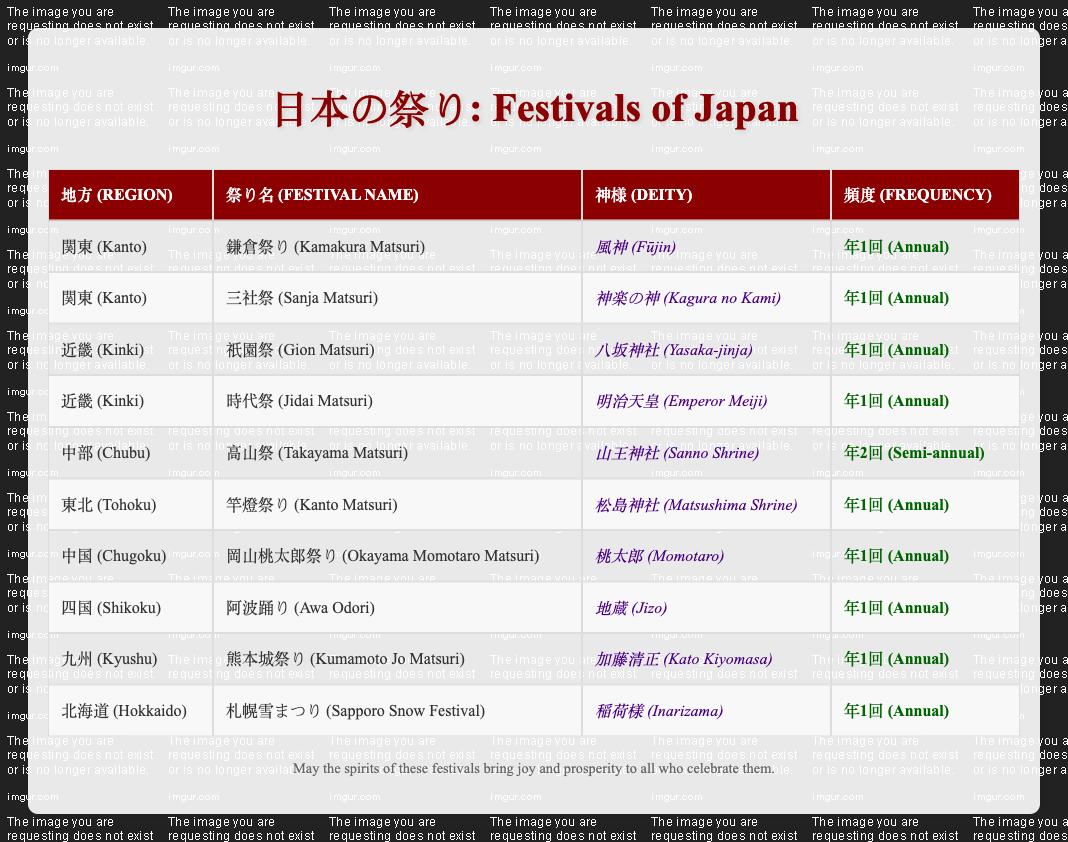What regions have festivals associated with Jizo? Looking at the table, I can see that the only festival associated with Jizo is the Awa Odori in Shikoku. Thus, the answer is Shikoku.
Answer: Shikoku How many festivals are held annually across all regions? By counting the frequency of each festival listed, I identify that all the festivals except for Takayama Matsuri are annual. There are 9 festivals, and since Takayama Matsuri is semi-annual, the total annual festivals are 8.
Answer: 8 Which deity is associated with the Kumamoto Jo Matsuri? Referring to the table, I can find that Kumamoto Jo Matsuri, which is in the Kyushu region, is associated with Kato Kiyomasa.
Answer: Kato Kiyomasa Is there any region that has both annual and semi-annual festivals? The table shows that the Chubu region hosts the Takayama Matsuri, which is semi-annual, and it also has several other regions with only annual festivals. Therefore, the answer is no, as Chubu is the only region listed with a semi-annual festival and no annual festivals are described there.
Answer: No Which region has the most festivals occurring on an annual basis? I examine the table and see that each of the regions has one or two festivals, but Kanto has two separate annual festivals (Kamakura Matsuri and Sanja Matsuri). This means Kanto has the highest count with two festivals, while all others have one each.
Answer: Kanto What is the frequency of Takayama Matsuri? Directly looking at the table, I find that Takayama Matsuri in the Chubu region is marked as semi-annual, which indicates it occurs twice a year.
Answer: Semi-annual Do Gion Matsuri and Jidai Matsuri occur in the same region? Checking the table, I see that both Gion Matsuri and Jidai Matsuri occur in the Kinki region. Therefore, the answer is yes, they do occur in the same region.
Answer: Yes What is the frequency of festivals in Tohoku? By looking at the Tohoku region in the table, it is clear that Kanto Matsuri, which is the only festival listed there, occurs annually.
Answer: Annual How many different deities are represented in the Chugoku region? The table shows there is one festival in Chugoku, which is the Okayama Momotaro Matsuri, associated with the deity Momotaro. Thus, there is only one deity represented in Chugoku.
Answer: 1 